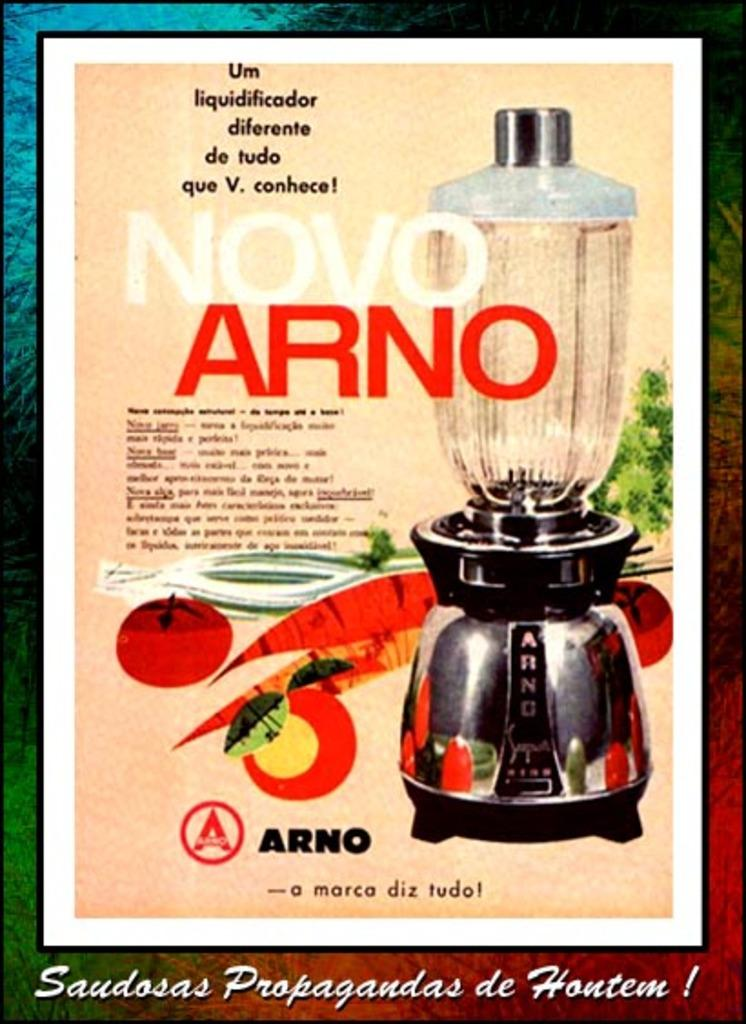<image>
Provide a brief description of the given image. An advertisement for a blender with the words Novo Arno 